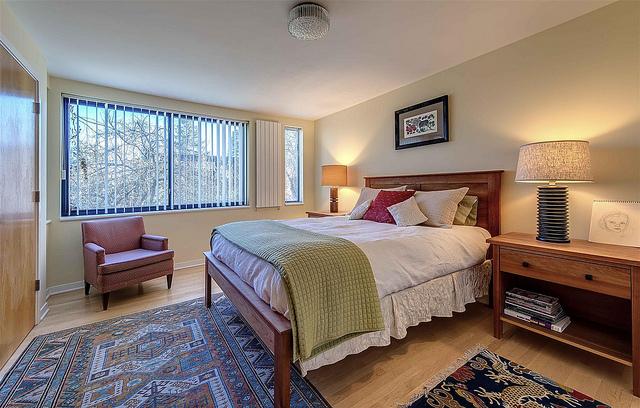What color is the middle pillow?
Answer briefly. Red. What is to the right of the right lamp?
Give a very brief answer. Picture. What ethnic style is the large rug at the foot of the bed?
Write a very short answer. Indian. 